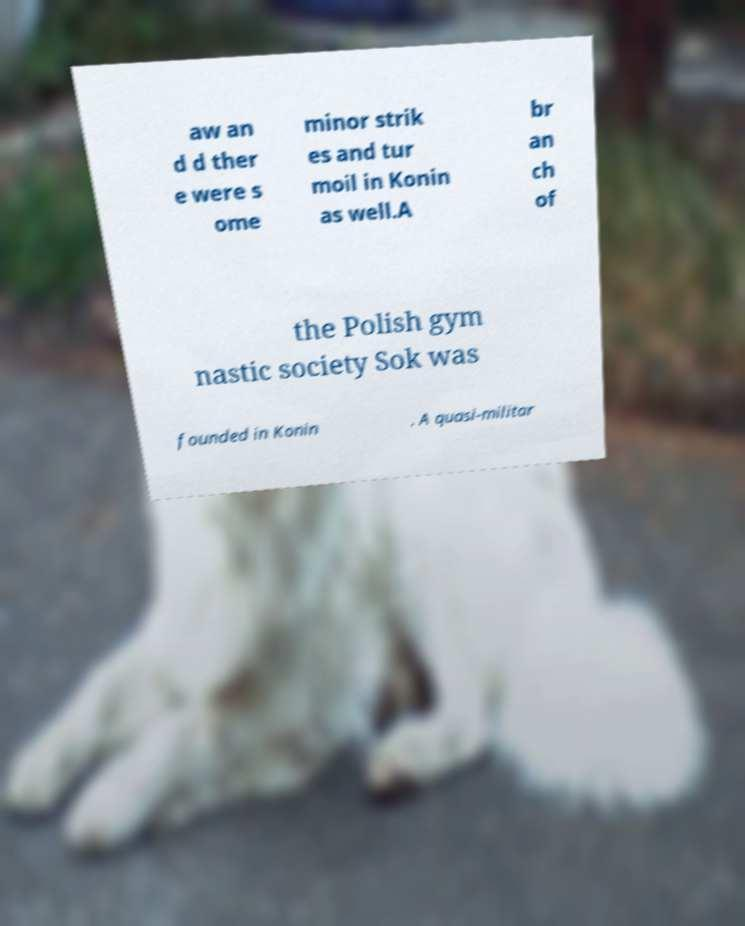Please read and relay the text visible in this image. What does it say? aw an d d ther e were s ome minor strik es and tur moil in Konin as well.A br an ch of the Polish gym nastic society Sok was founded in Konin . A quasi-militar 